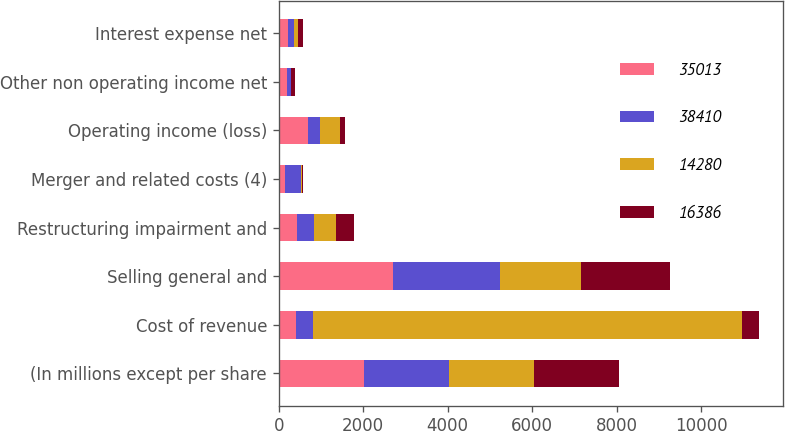<chart> <loc_0><loc_0><loc_500><loc_500><stacked_bar_chart><ecel><fcel>(In millions except per share<fcel>Cost of revenue<fcel>Selling general and<fcel>Restructuring impairment and<fcel>Merger and related costs (4)<fcel>Operating income (loss)<fcel>Other non operating income net<fcel>Interest expense net<nl><fcel>35013<fcel>2018<fcel>411<fcel>2699<fcel>433<fcel>153<fcel>701<fcel>202<fcel>223<nl><fcel>38410<fcel>2017<fcel>411<fcel>2535<fcel>412<fcel>373<fcel>284<fcel>80<fcel>131<nl><fcel>14280<fcel>2016<fcel>10150<fcel>1926<fcel>516<fcel>33<fcel>457<fcel>3<fcel>102<nl><fcel>16386<fcel>2015<fcel>411<fcel>2115<fcel>411<fcel>27<fcel>138<fcel>100<fcel>120<nl></chart> 